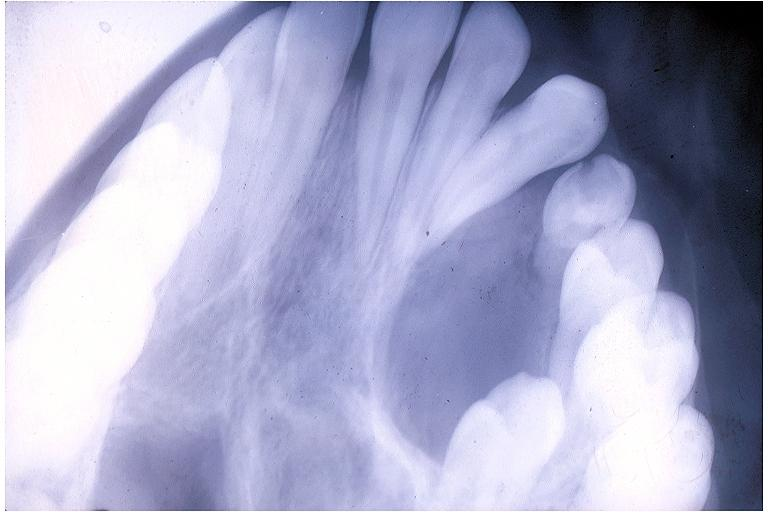does this image show adenomatoid odontogenic tumor?
Answer the question using a single word or phrase. Yes 